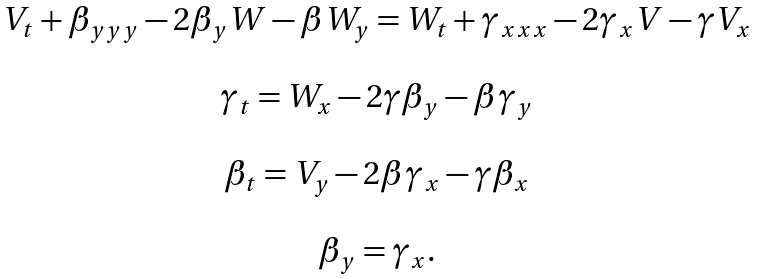<formula> <loc_0><loc_0><loc_500><loc_500>\begin{array} { c } V _ { t } + \beta _ { y y y } - 2 \beta _ { y } W - \beta W _ { y } = W _ { t } + \gamma _ { x x x } - 2 \gamma _ { x } V - \gamma V _ { x } \\ \ \\ \gamma _ { t } = W _ { x } - 2 \gamma \beta _ { y } - \beta \gamma _ { y } \\ \ \\ \beta _ { t } = V _ { y } - 2 \beta \gamma _ { x } - \gamma \beta _ { x } \\ \ \\ \beta _ { y } = \gamma _ { x } . \end{array}</formula> 